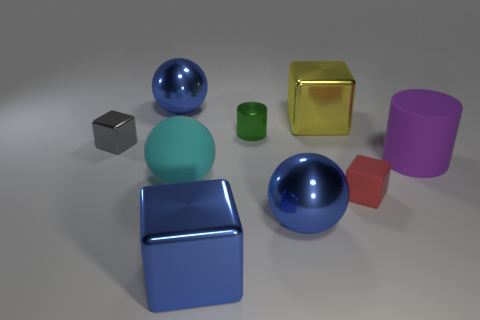Add 1 cylinders. How many objects exist? 10 Subtract all blocks. How many objects are left? 5 Subtract all brown metallic spheres. Subtract all gray metal blocks. How many objects are left? 8 Add 6 tiny gray shiny things. How many tiny gray shiny things are left? 7 Add 5 tiny cylinders. How many tiny cylinders exist? 6 Subtract 0 cyan cylinders. How many objects are left? 9 